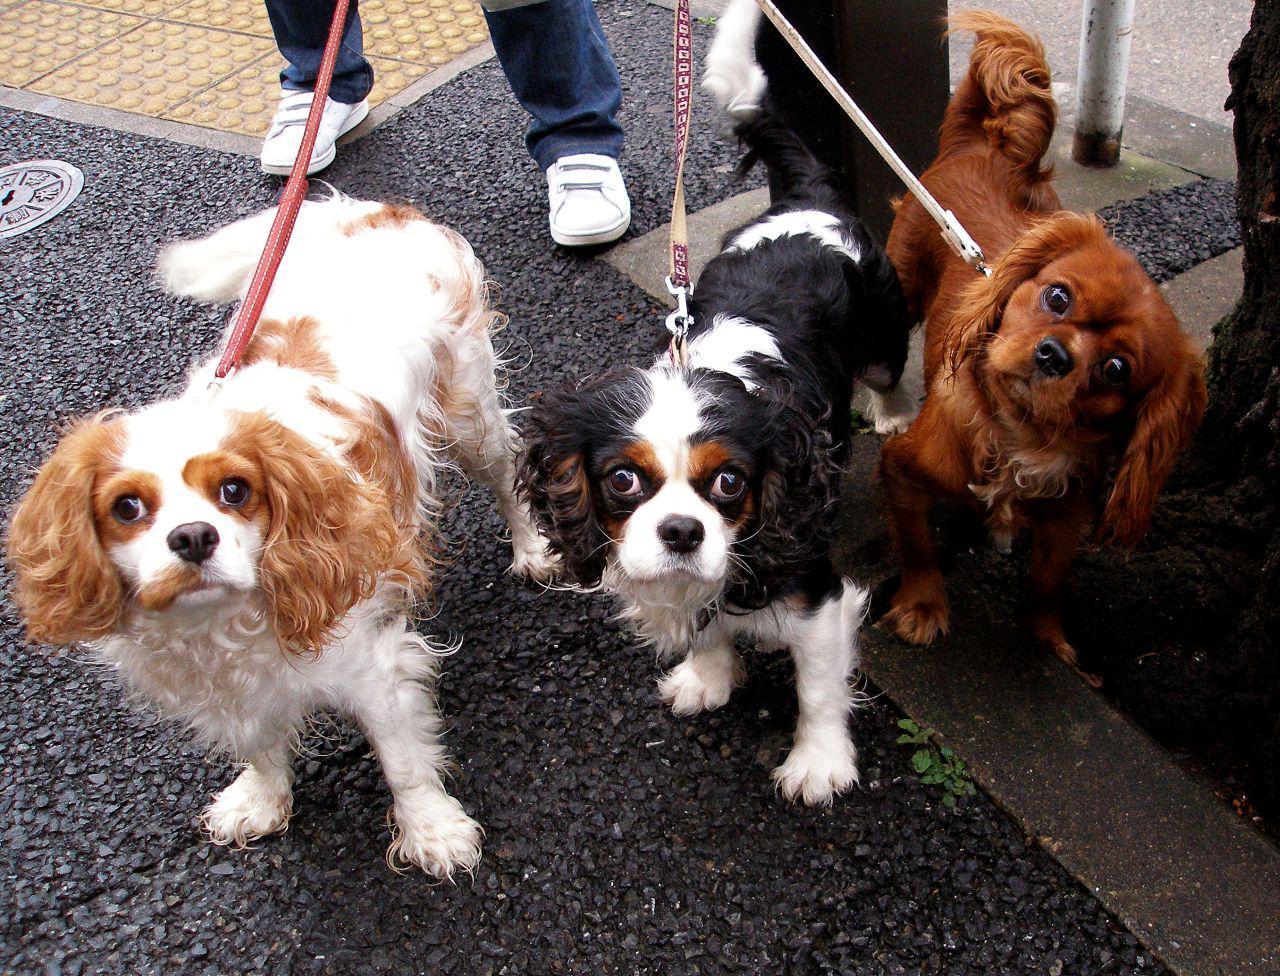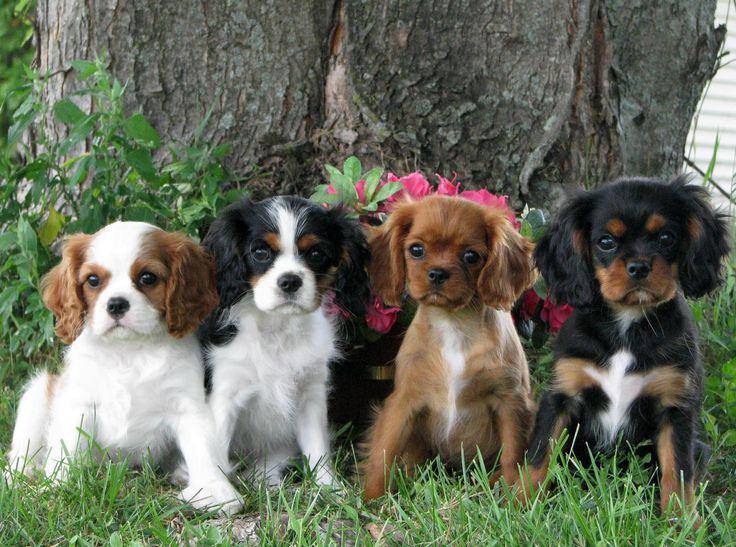The first image is the image on the left, the second image is the image on the right. Assess this claim about the two images: "In one image, a brown dog appears to try and kiss a brown and white dog under its chin". Correct or not? Answer yes or no. No. The first image is the image on the left, the second image is the image on the right. Assess this claim about the two images: "An orange spaniel is on the right of an orange-and-white spaniel, and they are face-to-face on the grass.". Correct or not? Answer yes or no. No. 